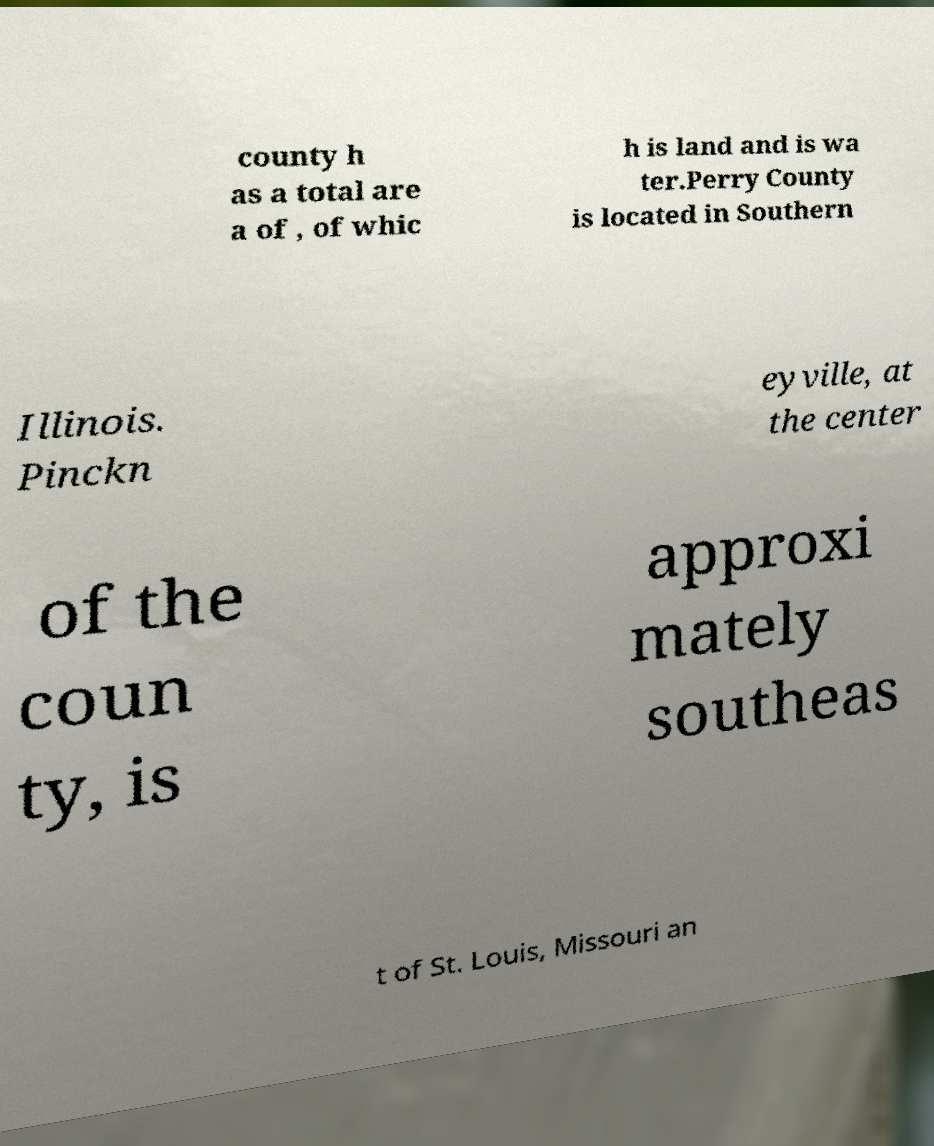Can you accurately transcribe the text from the provided image for me? county h as a total are a of , of whic h is land and is wa ter.Perry County is located in Southern Illinois. Pinckn eyville, at the center of the coun ty, is approxi mately southeas t of St. Louis, Missouri an 